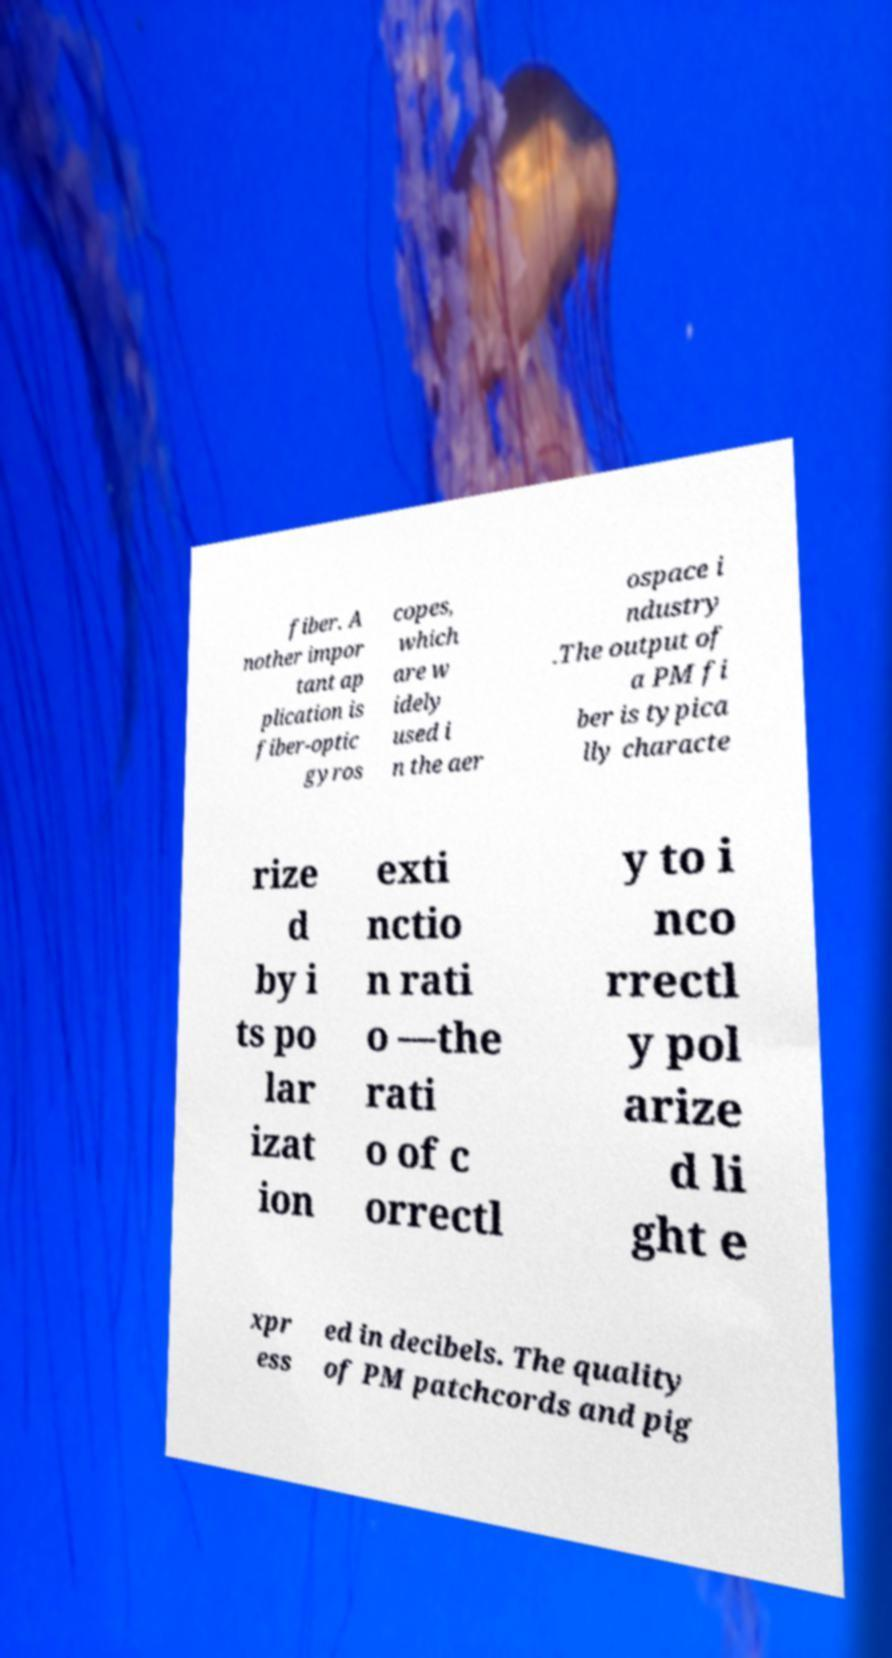For documentation purposes, I need the text within this image transcribed. Could you provide that? fiber. A nother impor tant ap plication is fiber-optic gyros copes, which are w idely used i n the aer ospace i ndustry .The output of a PM fi ber is typica lly characte rize d by i ts po lar izat ion exti nctio n rati o —the rati o of c orrectl y to i nco rrectl y pol arize d li ght e xpr ess ed in decibels. The quality of PM patchcords and pig 